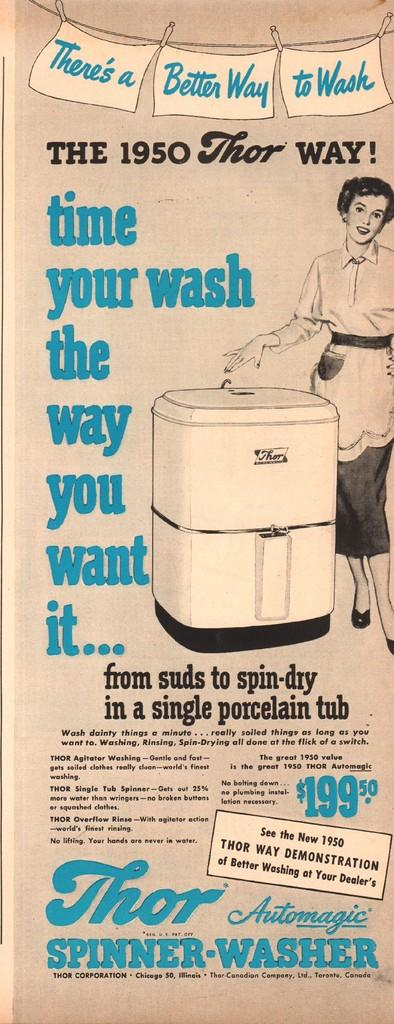<image>
Render a clear and concise summary of the photo. An ad for a Thor Automagic Spinner Washer selling for $199.50. 